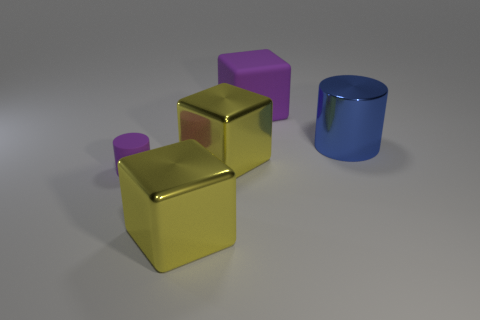Subtract all matte blocks. How many blocks are left? 2 Subtract all purple cubes. How many cubes are left? 2 Subtract 3 blocks. How many blocks are left? 0 Add 2 brown matte spheres. How many objects exist? 7 Subtract all green balls. How many green cylinders are left? 0 Subtract all green cylinders. Subtract all cyan spheres. How many cylinders are left? 2 Subtract all big cylinders. Subtract all small purple cylinders. How many objects are left? 3 Add 3 big blue shiny cylinders. How many big blue shiny cylinders are left? 4 Add 2 metal cylinders. How many metal cylinders exist? 3 Subtract 1 purple cylinders. How many objects are left? 4 